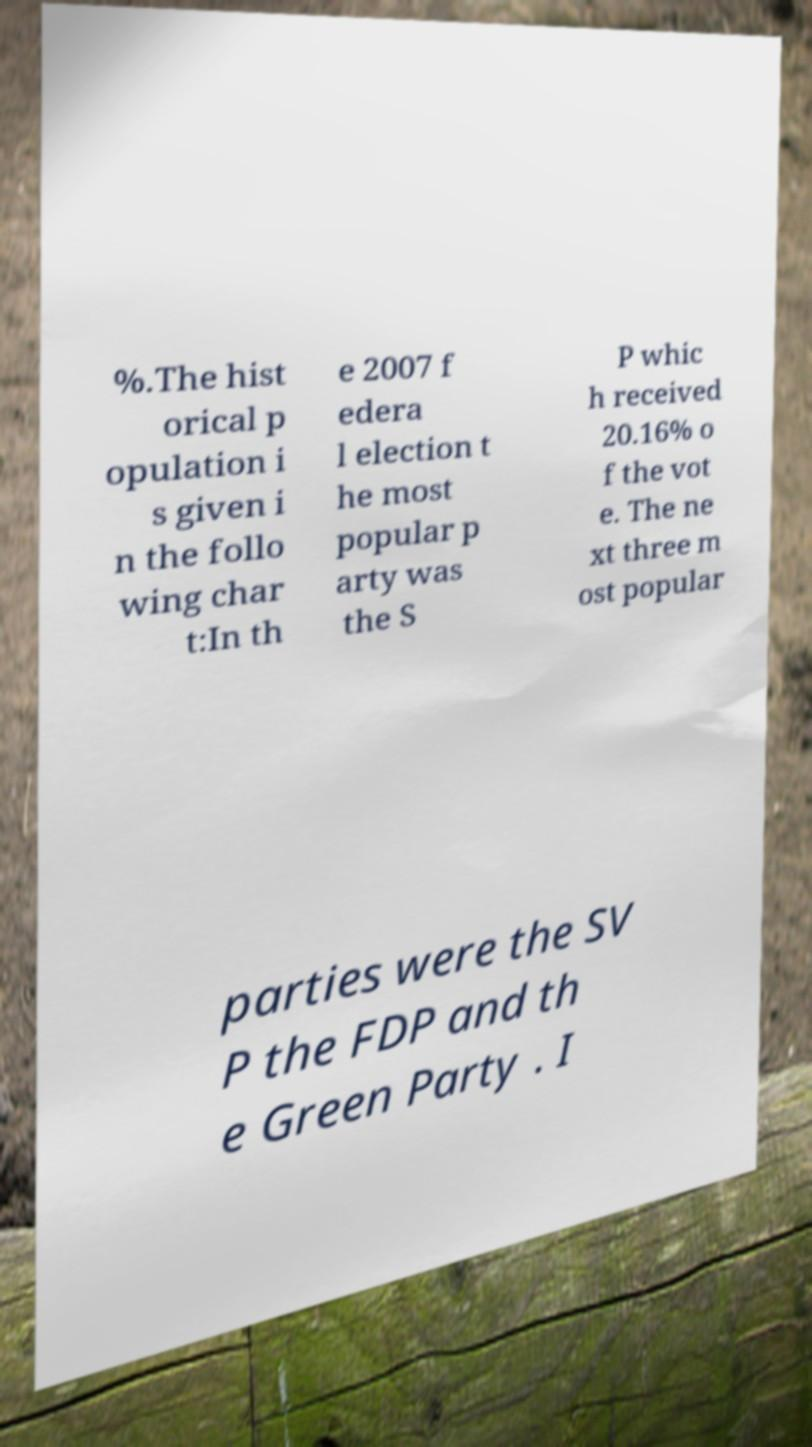Could you extract and type out the text from this image? %.The hist orical p opulation i s given i n the follo wing char t:In th e 2007 f edera l election t he most popular p arty was the S P whic h received 20.16% o f the vot e. The ne xt three m ost popular parties were the SV P the FDP and th e Green Party . I 